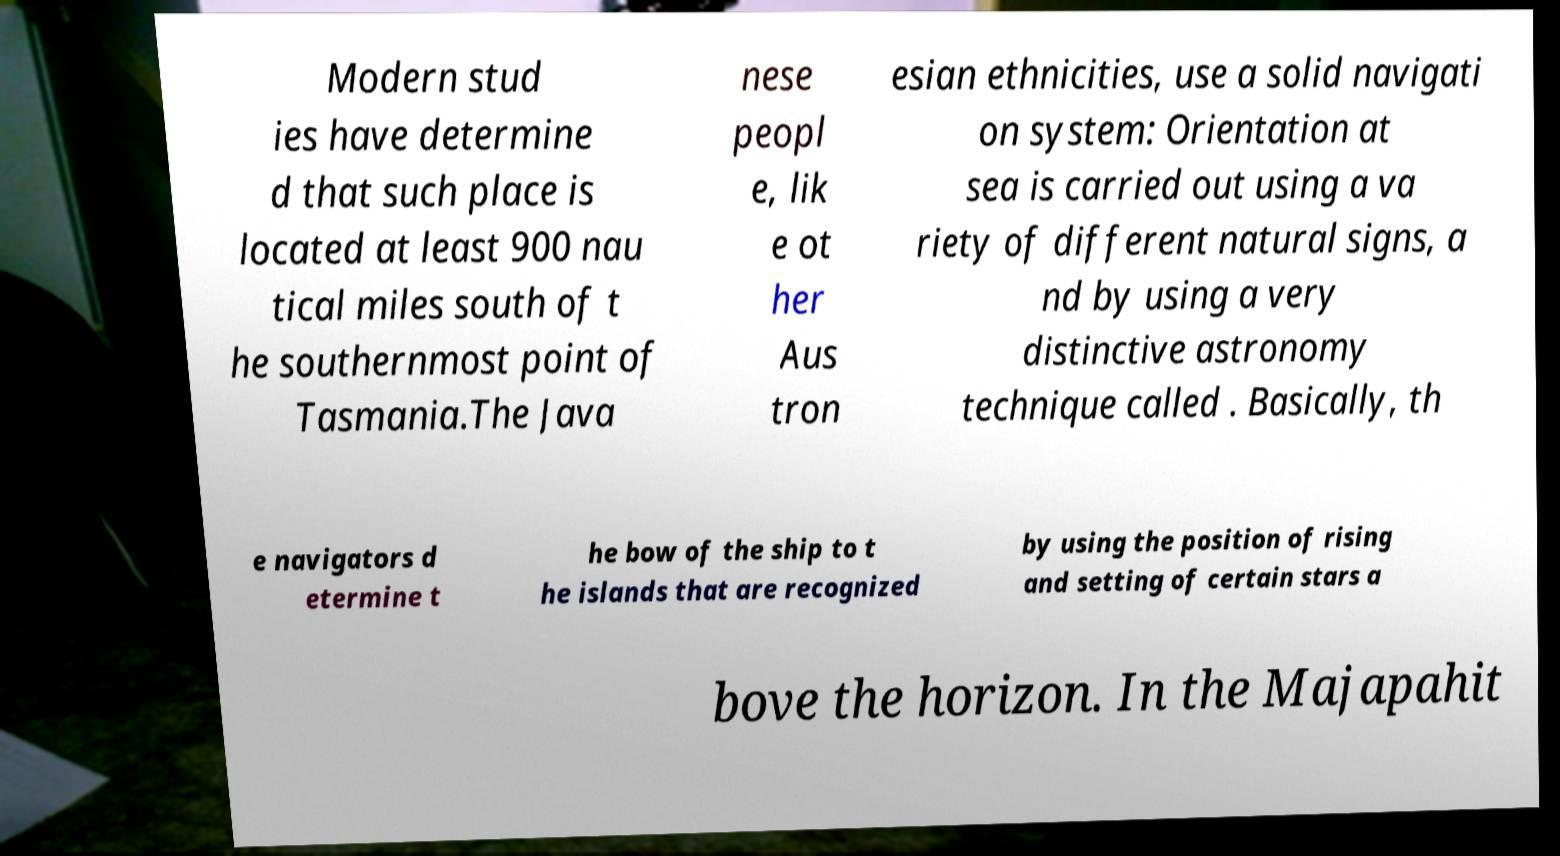For documentation purposes, I need the text within this image transcribed. Could you provide that? Modern stud ies have determine d that such place is located at least 900 nau tical miles south of t he southernmost point of Tasmania.The Java nese peopl e, lik e ot her Aus tron esian ethnicities, use a solid navigati on system: Orientation at sea is carried out using a va riety of different natural signs, a nd by using a very distinctive astronomy technique called . Basically, th e navigators d etermine t he bow of the ship to t he islands that are recognized by using the position of rising and setting of certain stars a bove the horizon. In the Majapahit 